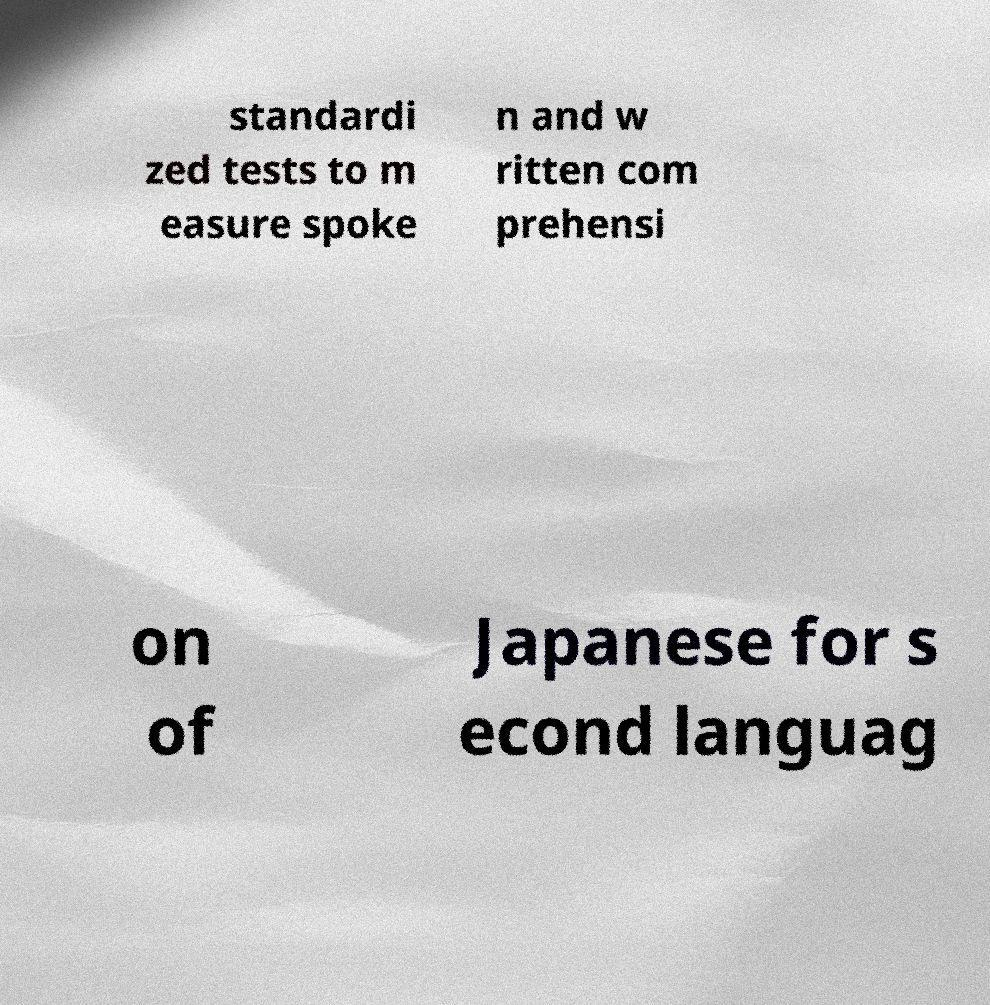Please identify and transcribe the text found in this image. standardi zed tests to m easure spoke n and w ritten com prehensi on of Japanese for s econd languag 